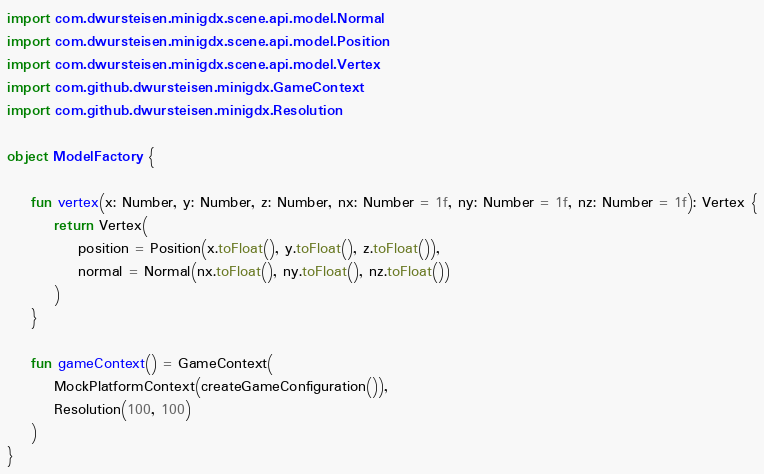<code> <loc_0><loc_0><loc_500><loc_500><_Kotlin_>import com.dwursteisen.minigdx.scene.api.model.Normal
import com.dwursteisen.minigdx.scene.api.model.Position
import com.dwursteisen.minigdx.scene.api.model.Vertex
import com.github.dwursteisen.minigdx.GameContext
import com.github.dwursteisen.minigdx.Resolution

object ModelFactory {

    fun vertex(x: Number, y: Number, z: Number, nx: Number = 1f, ny: Number = 1f, nz: Number = 1f): Vertex {
        return Vertex(
            position = Position(x.toFloat(), y.toFloat(), z.toFloat()),
            normal = Normal(nx.toFloat(), ny.toFloat(), nz.toFloat())
        )
    }

    fun gameContext() = GameContext(
        MockPlatformContext(createGameConfiguration()),
        Resolution(100, 100)
    )
}
</code> 